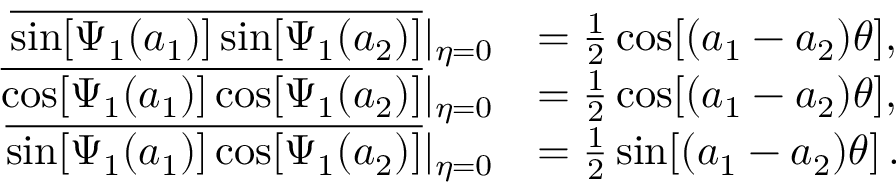Convert formula to latex. <formula><loc_0><loc_0><loc_500><loc_500>\begin{array} { r l } { \overline { { \sin [ \Psi _ { 1 } ( a _ { 1 } ) ] \sin [ \Psi _ { 1 } ( a _ { 2 } ) ] } } | _ { \eta = 0 } } & { = \frac { 1 } { 2 } \cos [ ( a _ { 1 } - a _ { 2 } ) \theta ] , } \\ { \overline { { \cos [ \Psi _ { 1 } ( a _ { 1 } ) ] \cos [ \Psi _ { 1 } ( a _ { 2 } ) ] } } | _ { \eta = 0 } } & { = \frac { 1 } { 2 } \cos [ ( a _ { 1 } - a _ { 2 } ) \theta ] , } \\ { \overline { { \sin [ \Psi _ { 1 } ( a _ { 1 } ) ] \cos [ \Psi _ { 1 } ( a _ { 2 } ) ] } } | _ { \eta = 0 } } & { = \frac { 1 } { 2 } \sin [ ( a _ { 1 } - a _ { 2 } ) \theta ] \, . } \end{array}</formula> 